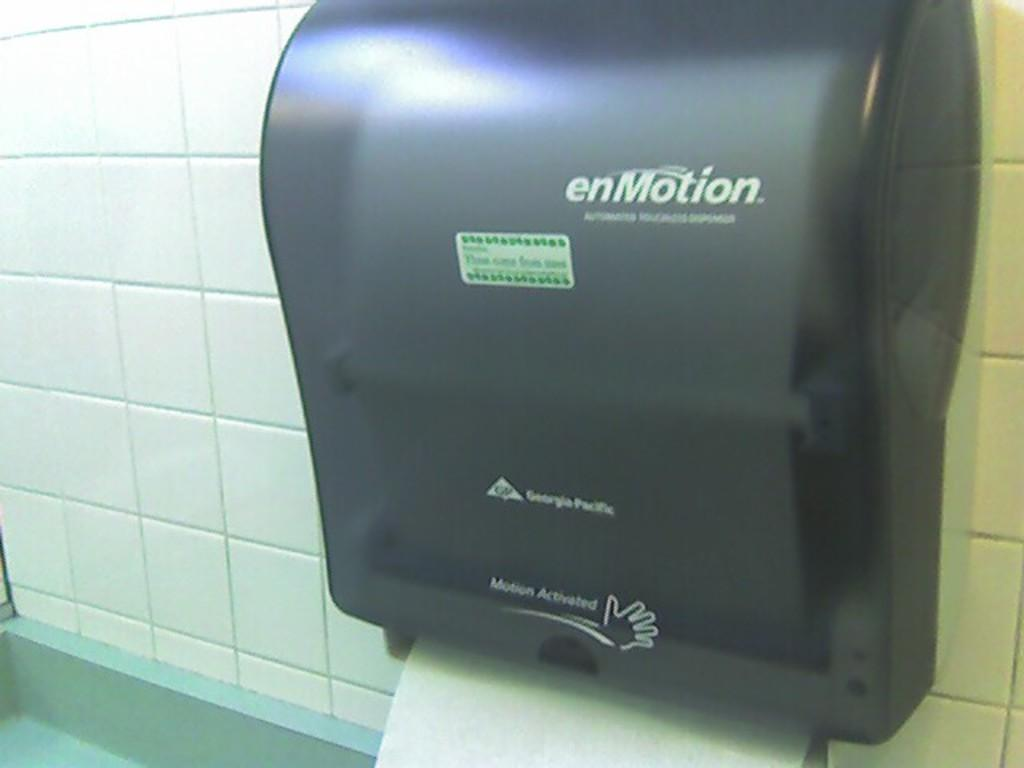What type of machine is in the image? There is a black hand drying machine in the image. What can be seen on the hand drying machine? There is something written on the hand drying machine. What color is the background wall in the image? The background wall is white. How many kittens are sitting on the vessel in the image? There is no vessel or kittens present in the image. What type of wound is visible on the hand drying machine? There is no wound visible on the hand drying machine; it is a machine designed for drying hands. 